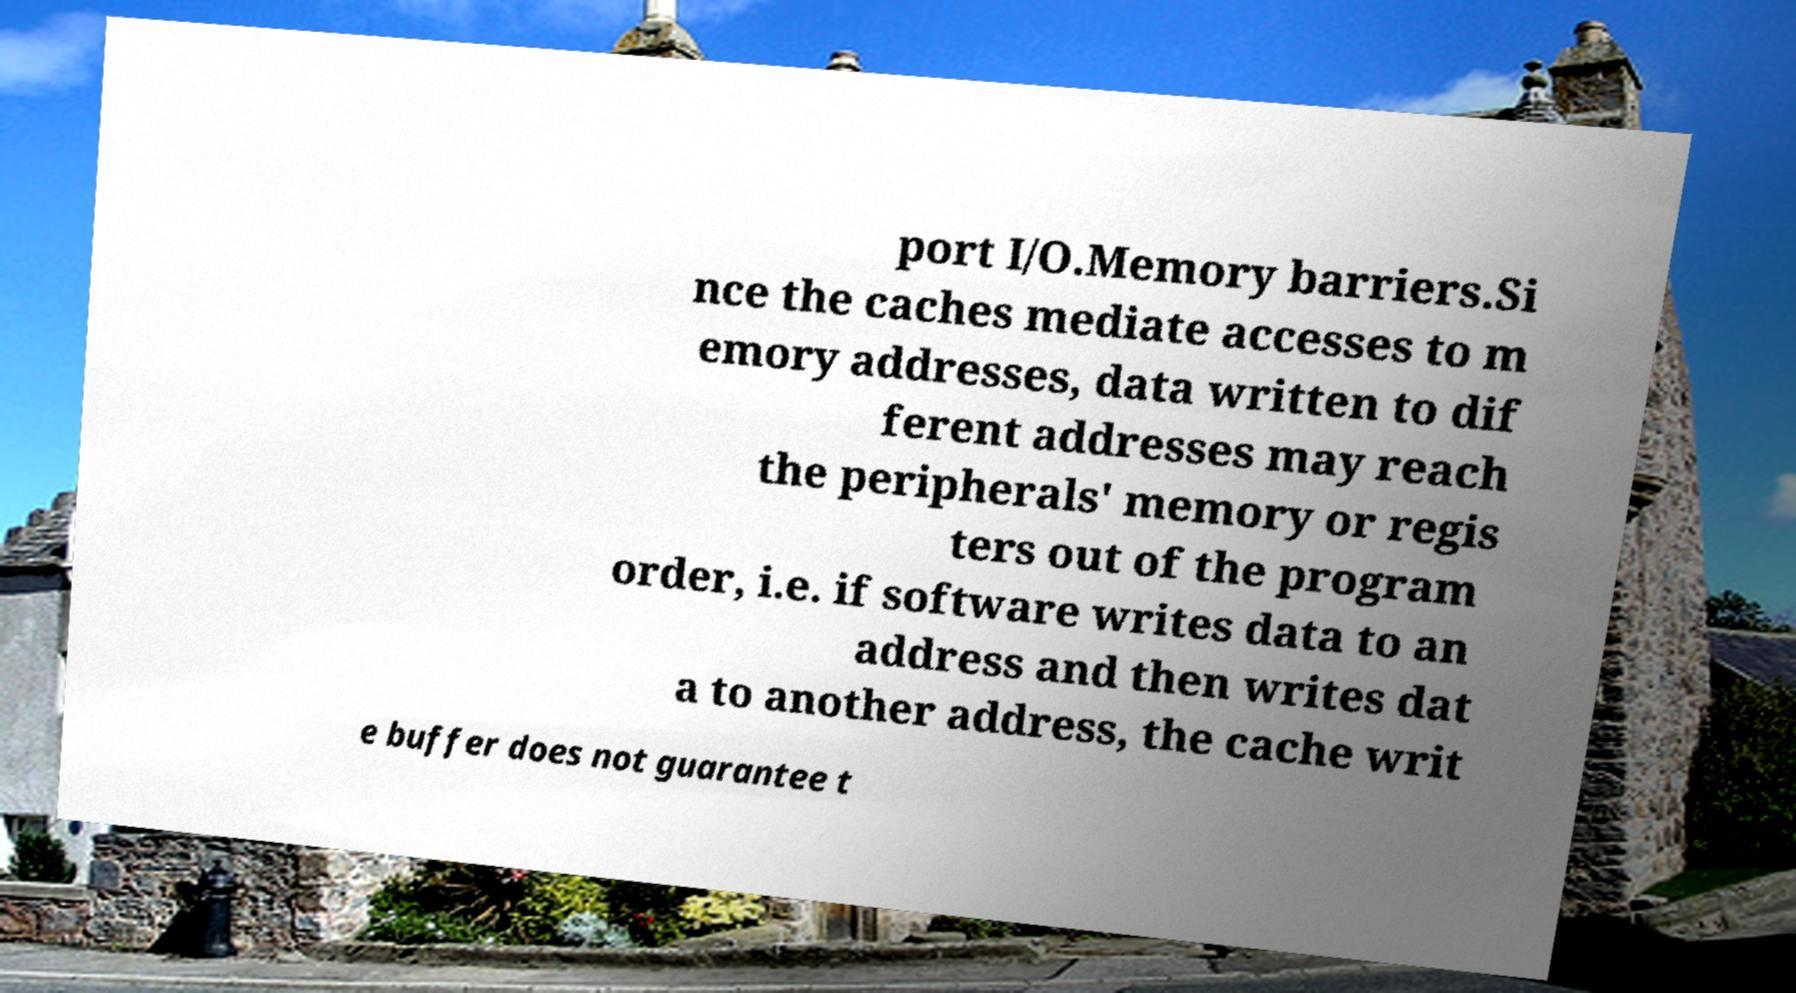Please read and relay the text visible in this image. What does it say? port I/O.Memory barriers.Si nce the caches mediate accesses to m emory addresses, data written to dif ferent addresses may reach the peripherals' memory or regis ters out of the program order, i.e. if software writes data to an address and then writes dat a to another address, the cache writ e buffer does not guarantee t 